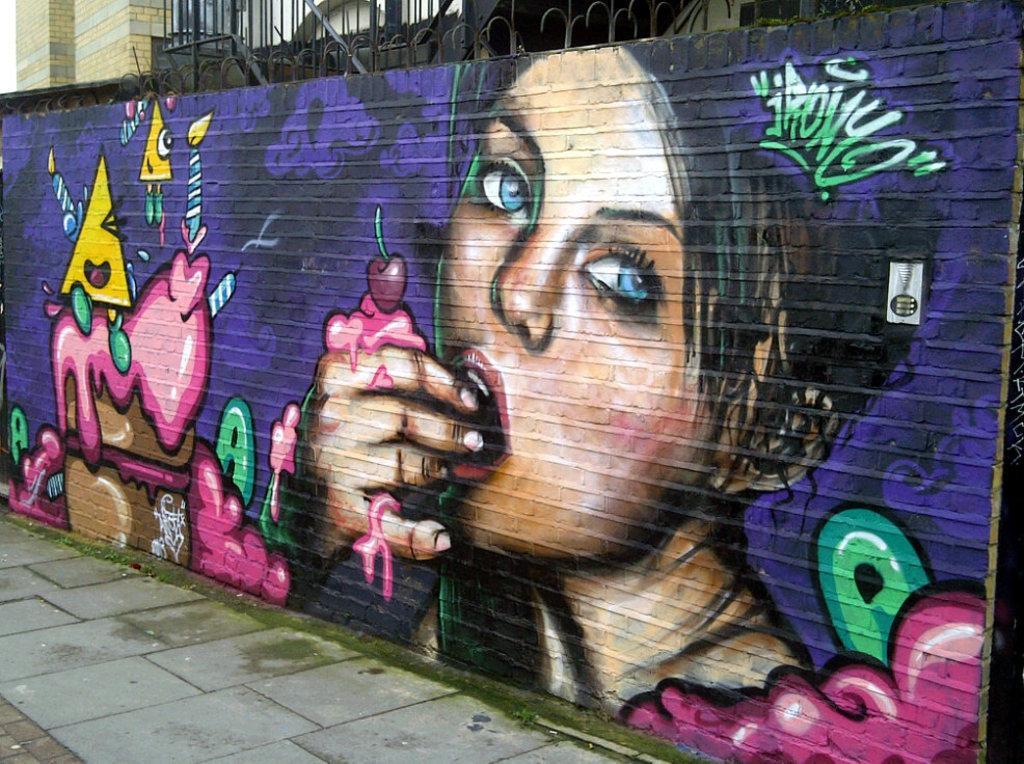Could you give a brief overview of what you see in this image? In this picture we can see a wall in the front, in the background there is a building, we can see graffiti of a person on this wall. 